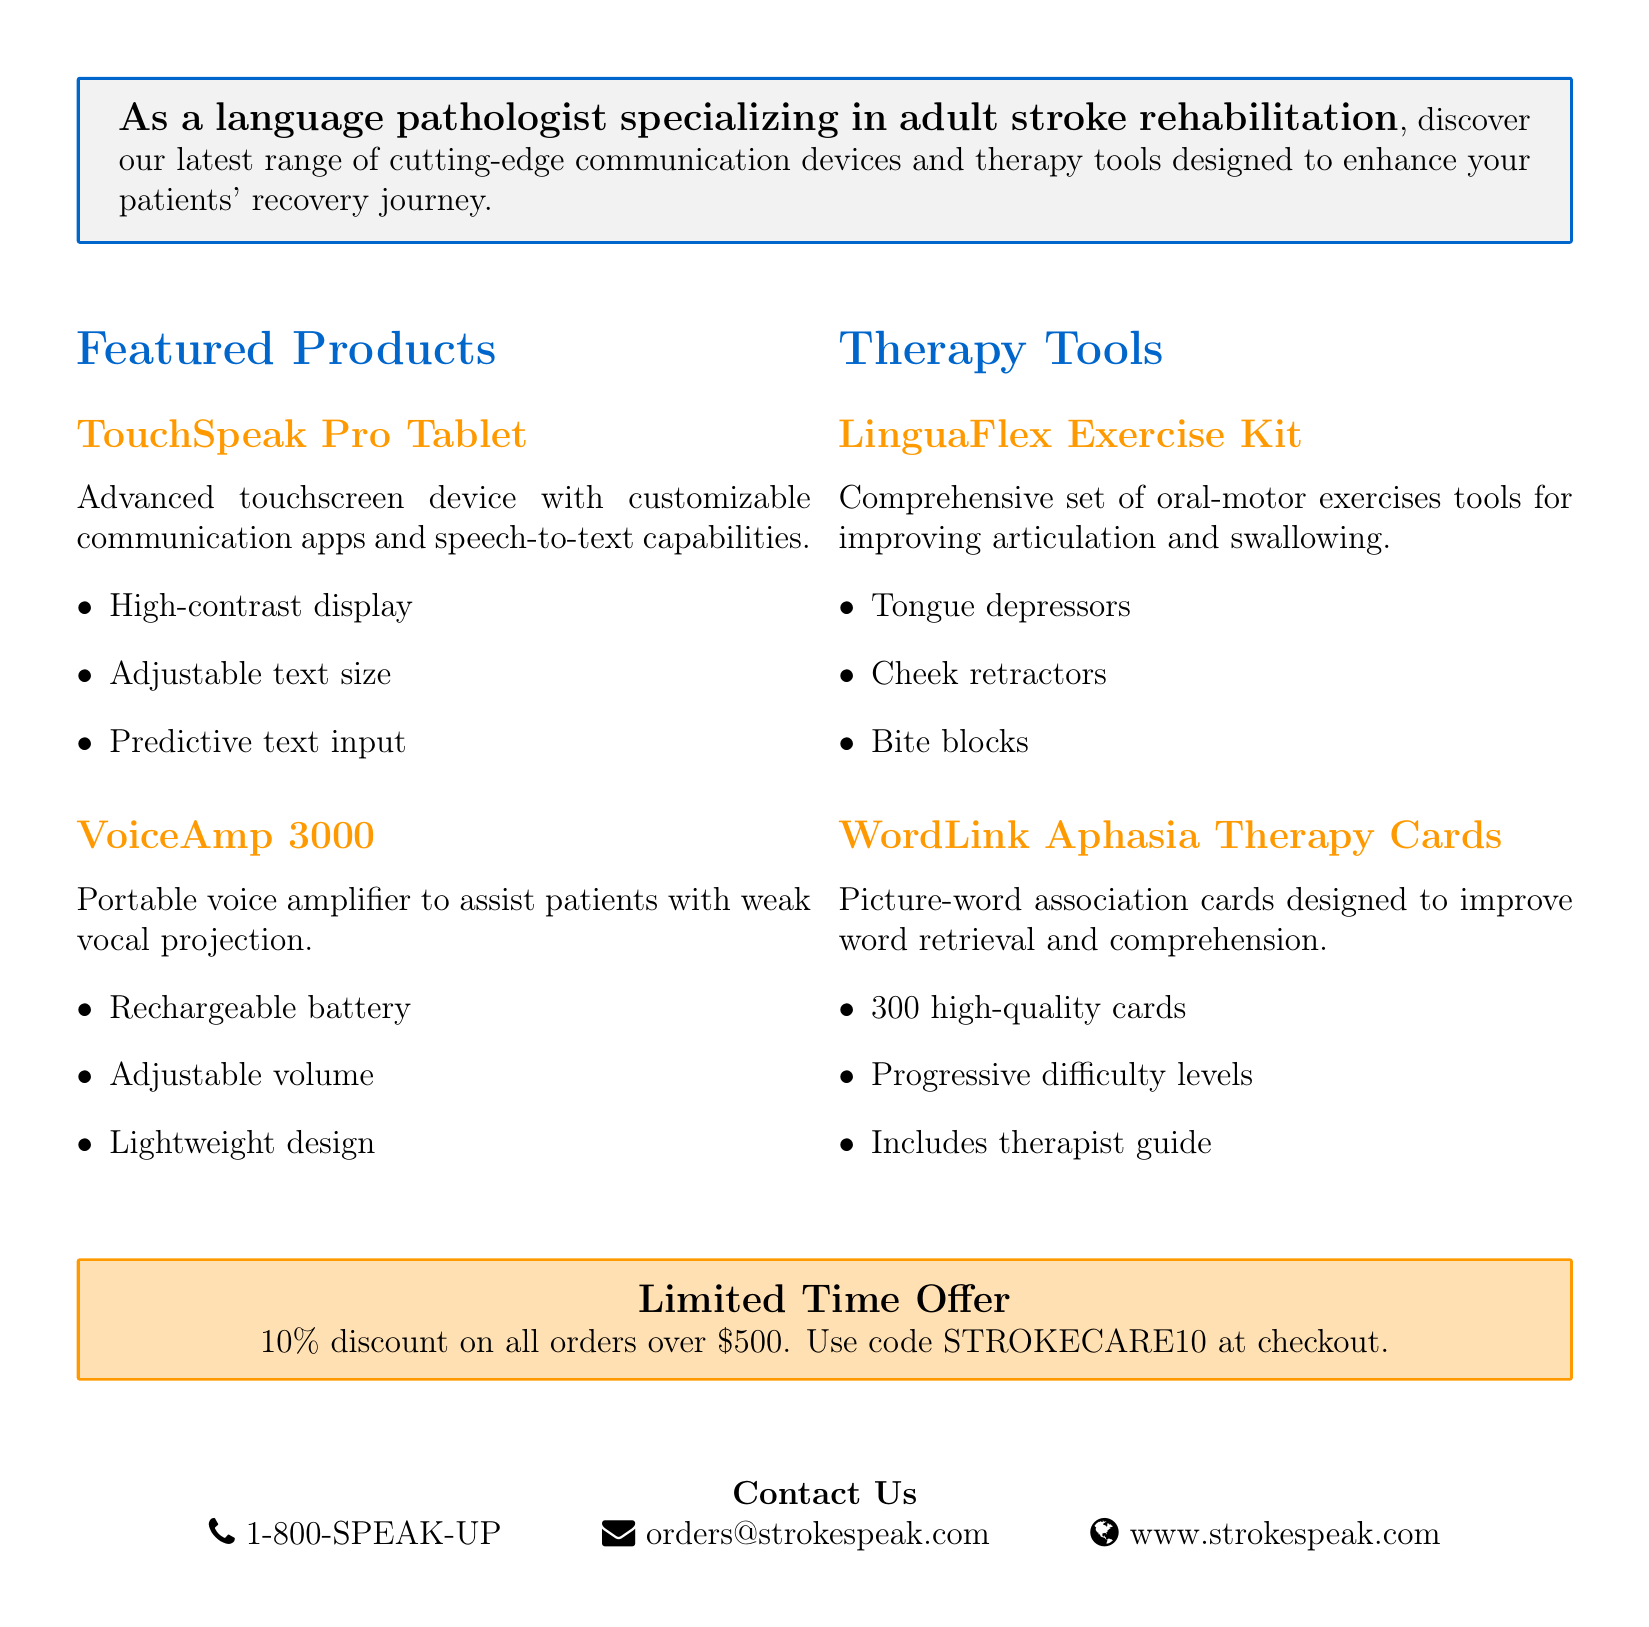What is the title of the document? The title is prominently displayed at the top of the document and indicates the focus on innovative communication solutions for stroke recovery.
Answer: StrokeSpeak: Innovative Communication Solutions What is the subtitle of the document? The subtitle provides further context about the content, specifically highlighting new assistive devices and therapy tools.
Answer: New Assistive Devices and Therapy Tools for Stroke Recovery What is the discount offered on orders over $500? The special offer clearly states the discount available for qualifying orders, making it an important detail for potential buyers.
Answer: 10% What is the name of the portable voice amplifier? This information is part of the featured products section, outlining specific tools designed for stroke recovery.
Answer: VoiceAmp 3000 What items are included in the LinguaFlex Exercise Kit? The document specifies the components of this therapy tool, highlighting its purpose in oral-motor exercises.
Answer: Tongue depressors, Cheek retractors, Bite blocks What type of cards are included in the WordLink Aphasia Therapy Cards? This question focuses on the specific nature of the therapy tool mentioned in the document, illustrating its design for stroke recovery.
Answer: Picture-word association cards What is the phone number provided for contact? This information is essential for readers seeking further assistance or to place an order, located in the contact information section.
Answer: 1-800-SPEAK-UP What is one key feature of the TouchSpeak Pro Tablet? The document lists multiple key features, making it important to know at least one to understand its capabilities.
Answer: High-contrast display What does the therapist guide for the WordLink Aphasia Therapy Cards provide? The inclusion of a therapist guide is highlighted in explaining the usability of the cards for professionals in the field.
Answer: Guidance on usage 